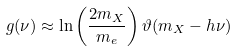Convert formula to latex. <formula><loc_0><loc_0><loc_500><loc_500>g ( \nu ) \approx \ln \left ( \frac { 2 m _ { X } } { m _ { e } } \right ) \vartheta ( m _ { X } - h \nu )</formula> 